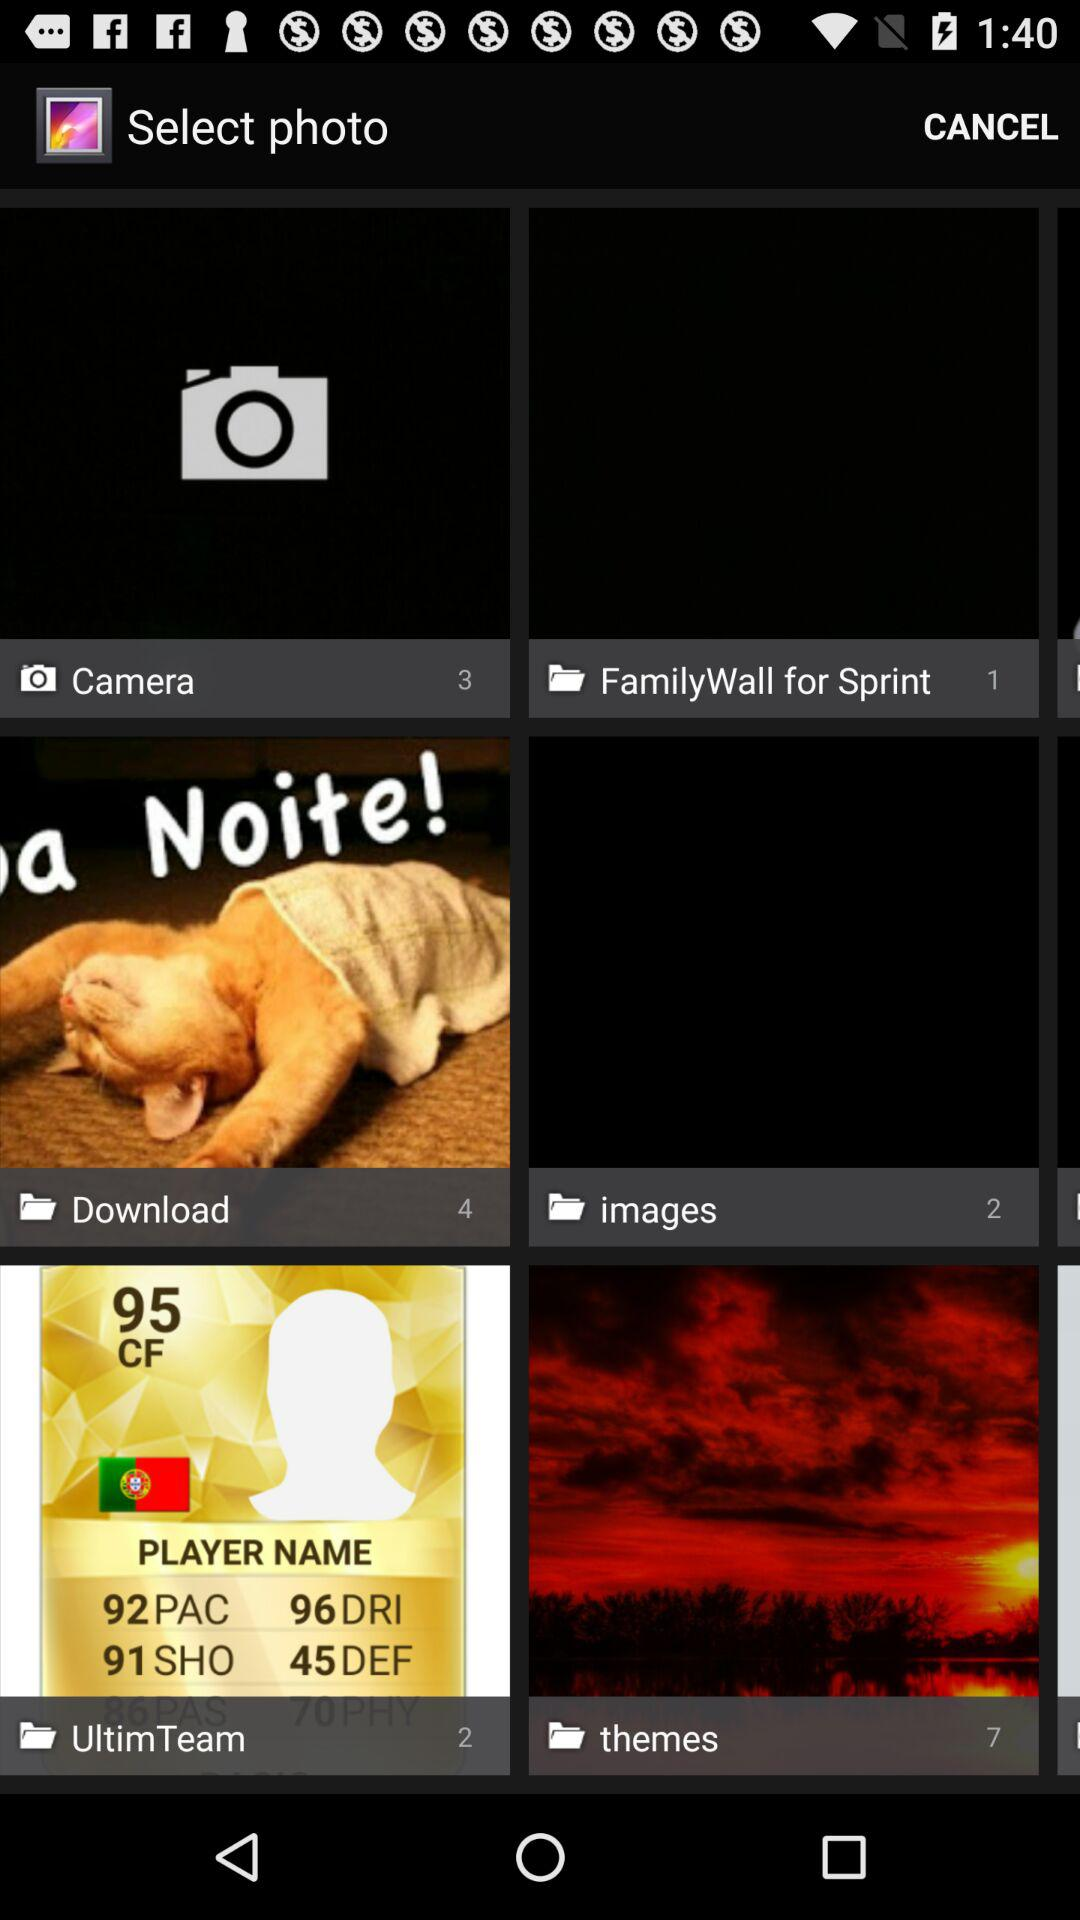Which folder has three images? The folder "Camera" has three images. 